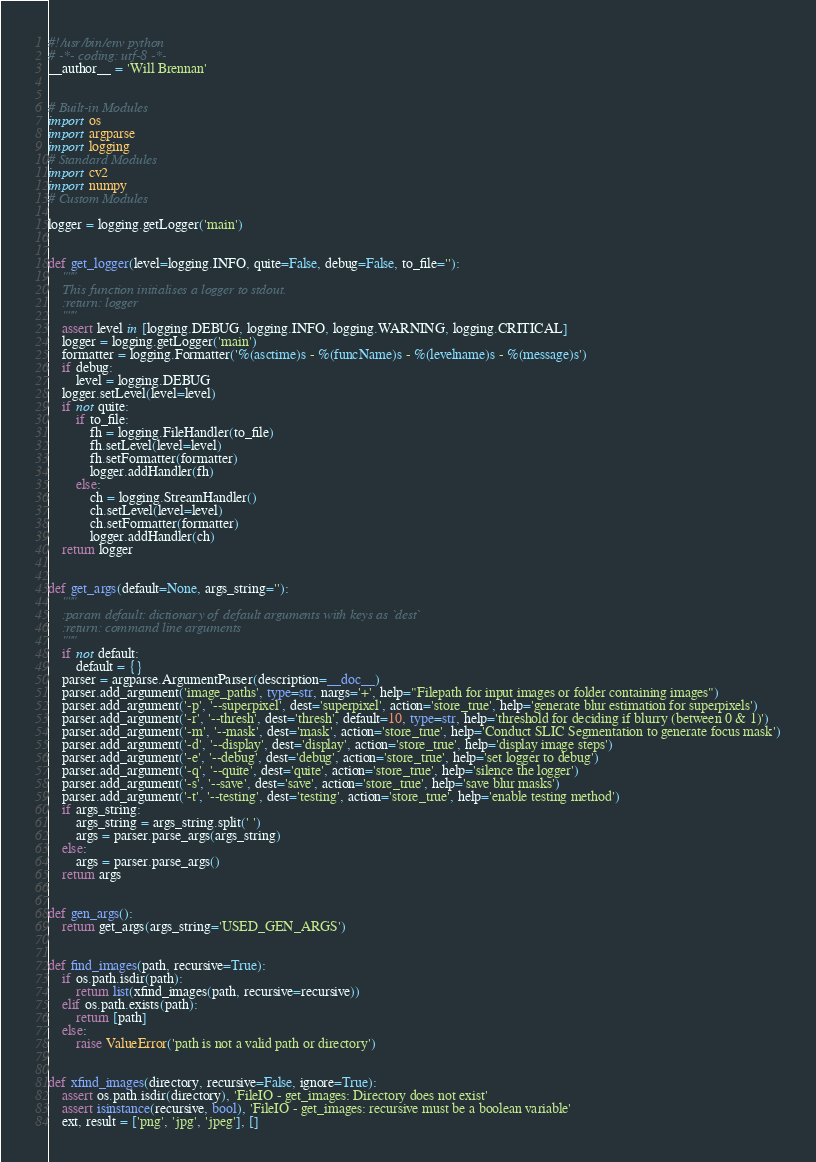<code> <loc_0><loc_0><loc_500><loc_500><_Python_>#!/usr/bin/env python
# -*- coding: utf-8 -*-
__author__ = 'Will Brennan'


# Built-in Modules
import os
import argparse
import logging
# Standard Modules
import cv2
import numpy
# Custom Modules

logger = logging.getLogger('main')


def get_logger(level=logging.INFO, quite=False, debug=False, to_file=''):
    """
    This function initialises a logger to stdout.
    :return: logger
    """
    assert level in [logging.DEBUG, logging.INFO, logging.WARNING, logging.CRITICAL]
    logger = logging.getLogger('main')
    formatter = logging.Formatter('%(asctime)s - %(funcName)s - %(levelname)s - %(message)s')
    if debug:
        level = logging.DEBUG
    logger.setLevel(level=level)
    if not quite:
        if to_file:
            fh = logging.FileHandler(to_file)
            fh.setLevel(level=level)
            fh.setFormatter(formatter)
            logger.addHandler(fh)
        else:
            ch = logging.StreamHandler()
            ch.setLevel(level=level)
            ch.setFormatter(formatter)
            logger.addHandler(ch)
    return logger


def get_args(default=None, args_string=''):
    """
    :param default: dictionary of default arguments with keys as `dest`
    :return: command line arguments
    """
    if not default:
        default = {}
    parser = argparse.ArgumentParser(description=__doc__)
    parser.add_argument('image_paths', type=str, nargs='+', help="Filepath for input images or folder containing images")
    parser.add_argument('-p', '--superpixel', dest='superpixel', action='store_true', help='generate blur estimation for superpixels')
    parser.add_argument('-r', '--thresh', dest='thresh', default=10, type=str, help='threshold for deciding if blurry (between 0 & 1)')
    parser.add_argument('-m', '--mask', dest='mask', action='store_true', help='Conduct SLIC Segmentation to generate focus mask')
    parser.add_argument('-d', '--display', dest='display', action='store_true', help='display image steps')
    parser.add_argument('-e', '--debug', dest='debug', action='store_true', help='set logger to debug')
    parser.add_argument('-q', '--quite', dest='quite', action='store_true', help='silence the logger')
    parser.add_argument('-s', '--save', dest='save', action='store_true', help='save blur masks')
    parser.add_argument('-t', '--testing', dest='testing', action='store_true', help='enable testing method')
    if args_string:
        args_string = args_string.split(' ')
        args = parser.parse_args(args_string)
    else:
        args = parser.parse_args()
    return args


def gen_args():
    return get_args(args_string='USED_GEN_ARGS')


def find_images(path, recursive=True):
    if os.path.isdir(path):
        return list(xfind_images(path, recursive=recursive))
    elif os.path.exists(path):
        return [path]
    else:
        raise ValueError('path is not a valid path or directory')


def xfind_images(directory, recursive=False, ignore=True):
    assert os.path.isdir(directory), 'FileIO - get_images: Directory does not exist'
    assert isinstance(recursive, bool), 'FileIO - get_images: recursive must be a boolean variable'
    ext, result = ['png', 'jpg', 'jpeg'], []</code> 